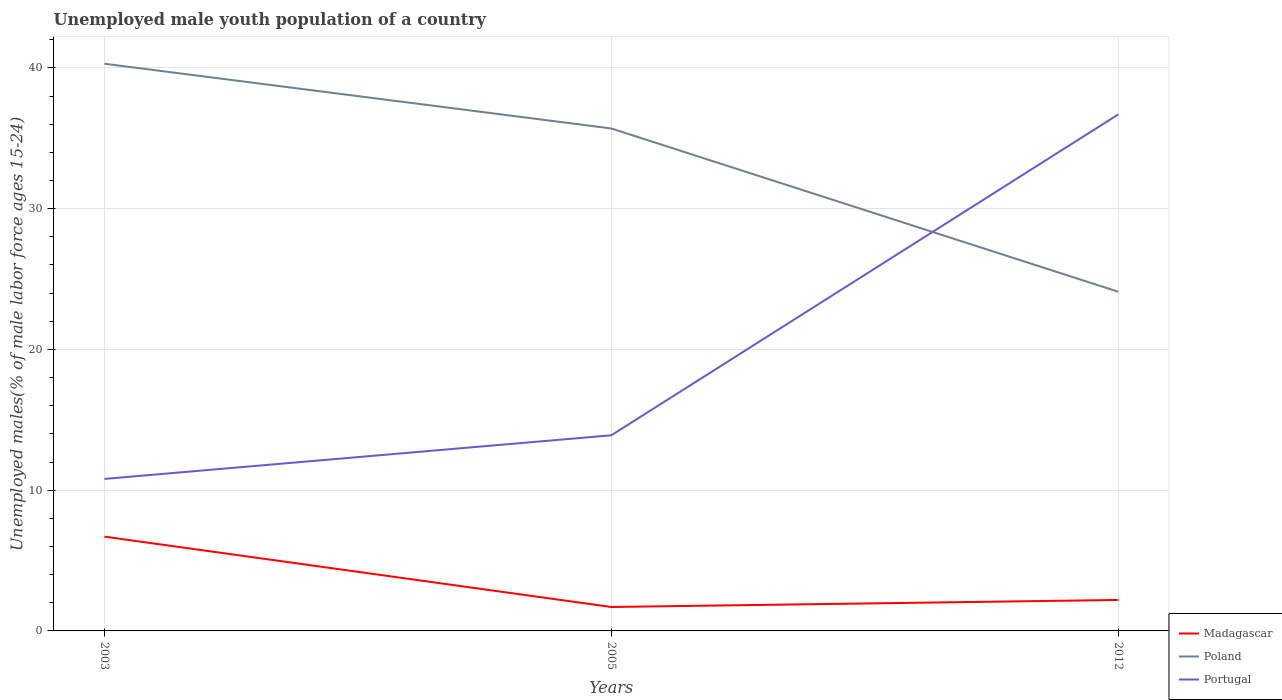Across all years, what is the maximum percentage of unemployed male youth population in Poland?
Your answer should be compact. 24.1. In which year was the percentage of unemployed male youth population in Portugal maximum?
Provide a short and direct response. 2003. What is the total percentage of unemployed male youth population in Madagascar in the graph?
Ensure brevity in your answer.  5. What is the difference between the highest and the second highest percentage of unemployed male youth population in Poland?
Provide a short and direct response. 16.2. How many lines are there?
Provide a short and direct response. 3. How many years are there in the graph?
Offer a very short reply. 3. Are the values on the major ticks of Y-axis written in scientific E-notation?
Your answer should be very brief. No. Where does the legend appear in the graph?
Make the answer very short. Bottom right. How many legend labels are there?
Provide a succinct answer. 3. What is the title of the graph?
Keep it short and to the point. Unemployed male youth population of a country. Does "Denmark" appear as one of the legend labels in the graph?
Offer a very short reply. No. What is the label or title of the Y-axis?
Your response must be concise. Unemployed males(% of male labor force ages 15-24). What is the Unemployed males(% of male labor force ages 15-24) in Madagascar in 2003?
Keep it short and to the point. 6.7. What is the Unemployed males(% of male labor force ages 15-24) of Poland in 2003?
Offer a terse response. 40.3. What is the Unemployed males(% of male labor force ages 15-24) in Portugal in 2003?
Keep it short and to the point. 10.8. What is the Unemployed males(% of male labor force ages 15-24) in Madagascar in 2005?
Offer a very short reply. 1.7. What is the Unemployed males(% of male labor force ages 15-24) in Poland in 2005?
Offer a very short reply. 35.7. What is the Unemployed males(% of male labor force ages 15-24) of Portugal in 2005?
Give a very brief answer. 13.9. What is the Unemployed males(% of male labor force ages 15-24) of Madagascar in 2012?
Offer a terse response. 2.2. What is the Unemployed males(% of male labor force ages 15-24) in Poland in 2012?
Your answer should be compact. 24.1. What is the Unemployed males(% of male labor force ages 15-24) in Portugal in 2012?
Your response must be concise. 36.7. Across all years, what is the maximum Unemployed males(% of male labor force ages 15-24) in Madagascar?
Offer a terse response. 6.7. Across all years, what is the maximum Unemployed males(% of male labor force ages 15-24) of Poland?
Your answer should be compact. 40.3. Across all years, what is the maximum Unemployed males(% of male labor force ages 15-24) of Portugal?
Give a very brief answer. 36.7. Across all years, what is the minimum Unemployed males(% of male labor force ages 15-24) in Madagascar?
Offer a very short reply. 1.7. Across all years, what is the minimum Unemployed males(% of male labor force ages 15-24) of Poland?
Provide a short and direct response. 24.1. Across all years, what is the minimum Unemployed males(% of male labor force ages 15-24) of Portugal?
Offer a very short reply. 10.8. What is the total Unemployed males(% of male labor force ages 15-24) of Poland in the graph?
Give a very brief answer. 100.1. What is the total Unemployed males(% of male labor force ages 15-24) of Portugal in the graph?
Ensure brevity in your answer.  61.4. What is the difference between the Unemployed males(% of male labor force ages 15-24) in Portugal in 2003 and that in 2005?
Provide a short and direct response. -3.1. What is the difference between the Unemployed males(% of male labor force ages 15-24) of Poland in 2003 and that in 2012?
Ensure brevity in your answer.  16.2. What is the difference between the Unemployed males(% of male labor force ages 15-24) in Portugal in 2003 and that in 2012?
Your answer should be very brief. -25.9. What is the difference between the Unemployed males(% of male labor force ages 15-24) of Poland in 2005 and that in 2012?
Your answer should be very brief. 11.6. What is the difference between the Unemployed males(% of male labor force ages 15-24) in Portugal in 2005 and that in 2012?
Keep it short and to the point. -22.8. What is the difference between the Unemployed males(% of male labor force ages 15-24) in Madagascar in 2003 and the Unemployed males(% of male labor force ages 15-24) in Poland in 2005?
Your answer should be very brief. -29. What is the difference between the Unemployed males(% of male labor force ages 15-24) of Madagascar in 2003 and the Unemployed males(% of male labor force ages 15-24) of Portugal in 2005?
Keep it short and to the point. -7.2. What is the difference between the Unemployed males(% of male labor force ages 15-24) in Poland in 2003 and the Unemployed males(% of male labor force ages 15-24) in Portugal in 2005?
Provide a succinct answer. 26.4. What is the difference between the Unemployed males(% of male labor force ages 15-24) of Madagascar in 2003 and the Unemployed males(% of male labor force ages 15-24) of Poland in 2012?
Ensure brevity in your answer.  -17.4. What is the difference between the Unemployed males(% of male labor force ages 15-24) of Poland in 2003 and the Unemployed males(% of male labor force ages 15-24) of Portugal in 2012?
Provide a succinct answer. 3.6. What is the difference between the Unemployed males(% of male labor force ages 15-24) of Madagascar in 2005 and the Unemployed males(% of male labor force ages 15-24) of Poland in 2012?
Your answer should be very brief. -22.4. What is the difference between the Unemployed males(% of male labor force ages 15-24) of Madagascar in 2005 and the Unemployed males(% of male labor force ages 15-24) of Portugal in 2012?
Your answer should be very brief. -35. What is the difference between the Unemployed males(% of male labor force ages 15-24) of Poland in 2005 and the Unemployed males(% of male labor force ages 15-24) of Portugal in 2012?
Your answer should be compact. -1. What is the average Unemployed males(% of male labor force ages 15-24) of Madagascar per year?
Offer a terse response. 3.53. What is the average Unemployed males(% of male labor force ages 15-24) in Poland per year?
Your response must be concise. 33.37. What is the average Unemployed males(% of male labor force ages 15-24) in Portugal per year?
Ensure brevity in your answer.  20.47. In the year 2003, what is the difference between the Unemployed males(% of male labor force ages 15-24) of Madagascar and Unemployed males(% of male labor force ages 15-24) of Poland?
Keep it short and to the point. -33.6. In the year 2003, what is the difference between the Unemployed males(% of male labor force ages 15-24) in Poland and Unemployed males(% of male labor force ages 15-24) in Portugal?
Provide a short and direct response. 29.5. In the year 2005, what is the difference between the Unemployed males(% of male labor force ages 15-24) of Madagascar and Unemployed males(% of male labor force ages 15-24) of Poland?
Your response must be concise. -34. In the year 2005, what is the difference between the Unemployed males(% of male labor force ages 15-24) of Poland and Unemployed males(% of male labor force ages 15-24) of Portugal?
Provide a short and direct response. 21.8. In the year 2012, what is the difference between the Unemployed males(% of male labor force ages 15-24) in Madagascar and Unemployed males(% of male labor force ages 15-24) in Poland?
Your response must be concise. -21.9. In the year 2012, what is the difference between the Unemployed males(% of male labor force ages 15-24) of Madagascar and Unemployed males(% of male labor force ages 15-24) of Portugal?
Keep it short and to the point. -34.5. In the year 2012, what is the difference between the Unemployed males(% of male labor force ages 15-24) of Poland and Unemployed males(% of male labor force ages 15-24) of Portugal?
Make the answer very short. -12.6. What is the ratio of the Unemployed males(% of male labor force ages 15-24) of Madagascar in 2003 to that in 2005?
Give a very brief answer. 3.94. What is the ratio of the Unemployed males(% of male labor force ages 15-24) of Poland in 2003 to that in 2005?
Ensure brevity in your answer.  1.13. What is the ratio of the Unemployed males(% of male labor force ages 15-24) of Portugal in 2003 to that in 2005?
Make the answer very short. 0.78. What is the ratio of the Unemployed males(% of male labor force ages 15-24) in Madagascar in 2003 to that in 2012?
Ensure brevity in your answer.  3.05. What is the ratio of the Unemployed males(% of male labor force ages 15-24) of Poland in 2003 to that in 2012?
Your answer should be compact. 1.67. What is the ratio of the Unemployed males(% of male labor force ages 15-24) in Portugal in 2003 to that in 2012?
Make the answer very short. 0.29. What is the ratio of the Unemployed males(% of male labor force ages 15-24) of Madagascar in 2005 to that in 2012?
Give a very brief answer. 0.77. What is the ratio of the Unemployed males(% of male labor force ages 15-24) in Poland in 2005 to that in 2012?
Your answer should be very brief. 1.48. What is the ratio of the Unemployed males(% of male labor force ages 15-24) in Portugal in 2005 to that in 2012?
Give a very brief answer. 0.38. What is the difference between the highest and the second highest Unemployed males(% of male labor force ages 15-24) in Madagascar?
Your response must be concise. 4.5. What is the difference between the highest and the second highest Unemployed males(% of male labor force ages 15-24) of Portugal?
Offer a terse response. 22.8. What is the difference between the highest and the lowest Unemployed males(% of male labor force ages 15-24) in Portugal?
Ensure brevity in your answer.  25.9. 